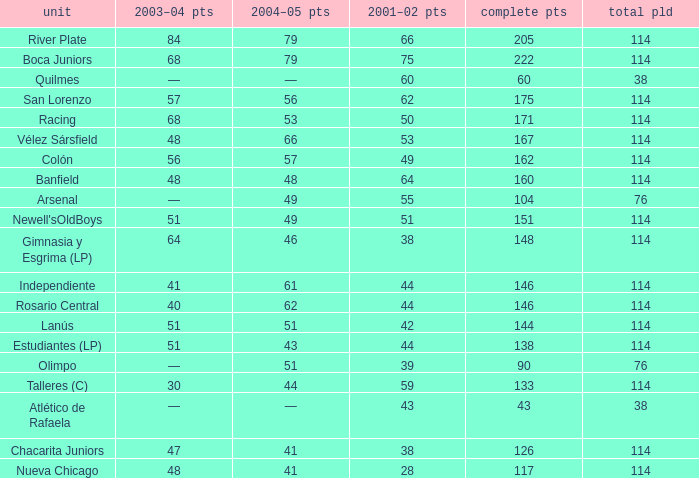Can you parse all the data within this table? {'header': ['unit', '2003–04 pts', '2004–05 pts', '2001–02 pts', 'complete pts', 'total pld'], 'rows': [['River Plate', '84', '79', '66', '205', '114'], ['Boca Juniors', '68', '79', '75', '222', '114'], ['Quilmes', '—', '—', '60', '60', '38'], ['San Lorenzo', '57', '56', '62', '175', '114'], ['Racing', '68', '53', '50', '171', '114'], ['Vélez Sársfield', '48', '66', '53', '167', '114'], ['Colón', '56', '57', '49', '162', '114'], ['Banfield', '48', '48', '64', '160', '114'], ['Arsenal', '—', '49', '55', '104', '76'], ["Newell'sOldBoys", '51', '49', '51', '151', '114'], ['Gimnasia y Esgrima (LP)', '64', '46', '38', '148', '114'], ['Independiente', '41', '61', '44', '146', '114'], ['Rosario Central', '40', '62', '44', '146', '114'], ['Lanús', '51', '51', '42', '144', '114'], ['Estudiantes (LP)', '51', '43', '44', '138', '114'], ['Olimpo', '—', '51', '39', '90', '76'], ['Talleres (C)', '30', '44', '59', '133', '114'], ['Atlético de Rafaela', '—', '—', '43', '43', '38'], ['Chacarita Juniors', '47', '41', '38', '126', '114'], ['Nueva Chicago', '48', '41', '28', '117', '114']]} Which Total Pts have a 2001–02 Pts smaller than 38? 117.0. 